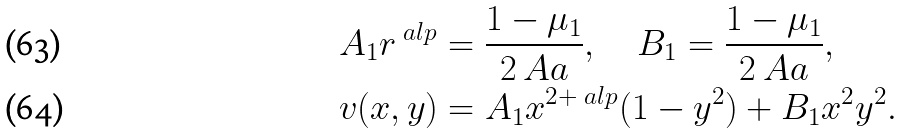<formula> <loc_0><loc_0><loc_500><loc_500>& A _ { 1 } r ^ { \ a l p } = \frac { 1 - \mu _ { 1 } } { 2 \ A a } , \quad B _ { 1 } = \frac { 1 - \mu _ { 1 } } { 2 \ A a } , \\ & v ( x , y ) = A _ { 1 } x ^ { 2 + \ a l p } ( 1 - y ^ { 2 } ) + B _ { 1 } x ^ { 2 } y ^ { 2 } .</formula> 